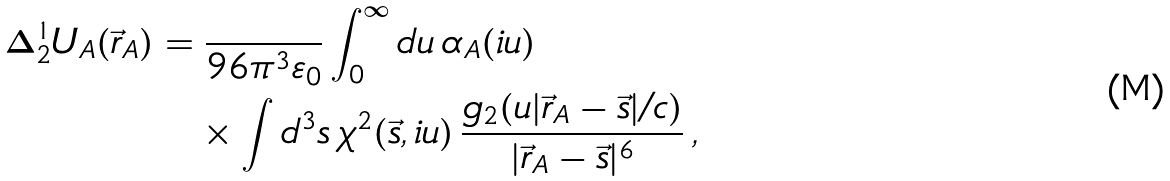<formula> <loc_0><loc_0><loc_500><loc_500>\Delta _ { 2 } ^ { 1 } U _ { A } ( \vec { r } _ { A } ) & = \frac { } { 9 6 \pi ^ { 3 } \varepsilon _ { 0 } } \int _ { 0 } ^ { \infty } d u \, \alpha _ { A } ( i u ) \\ & \quad \times \int d ^ { 3 } s \, \chi ^ { 2 } ( \vec { s } , i u ) \, \frac { g _ { 2 } ( u | \vec { r } _ { A } - \vec { s } | / c ) } { | \vec { r } _ { A } - \vec { s } | ^ { 6 } } \, ,</formula> 